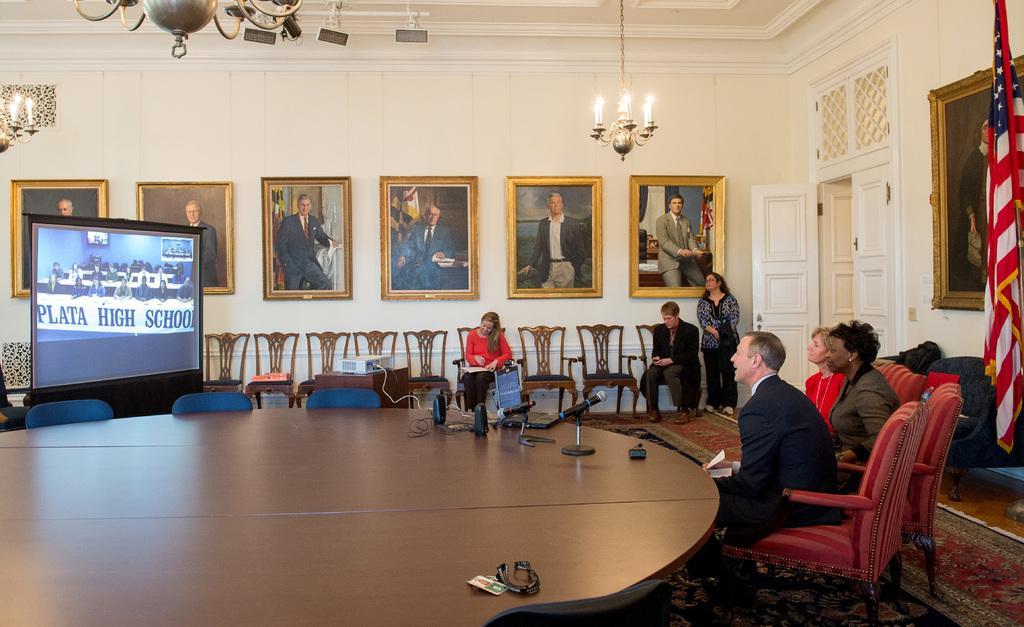Can you describe this image briefly? Different type of pictures on wall. Lights are attached to ceiling. These persons are sitting on chairs. Beside this man a woman is standing. On this table there is a mic, id card, laptop and speakers. Far there is a screen, in this screen persons are sitting on chairs, on this table there is a banner. Backside of this person's there is a flag. A floor with carpet. On this table there is a projector. This is white door with handle. 